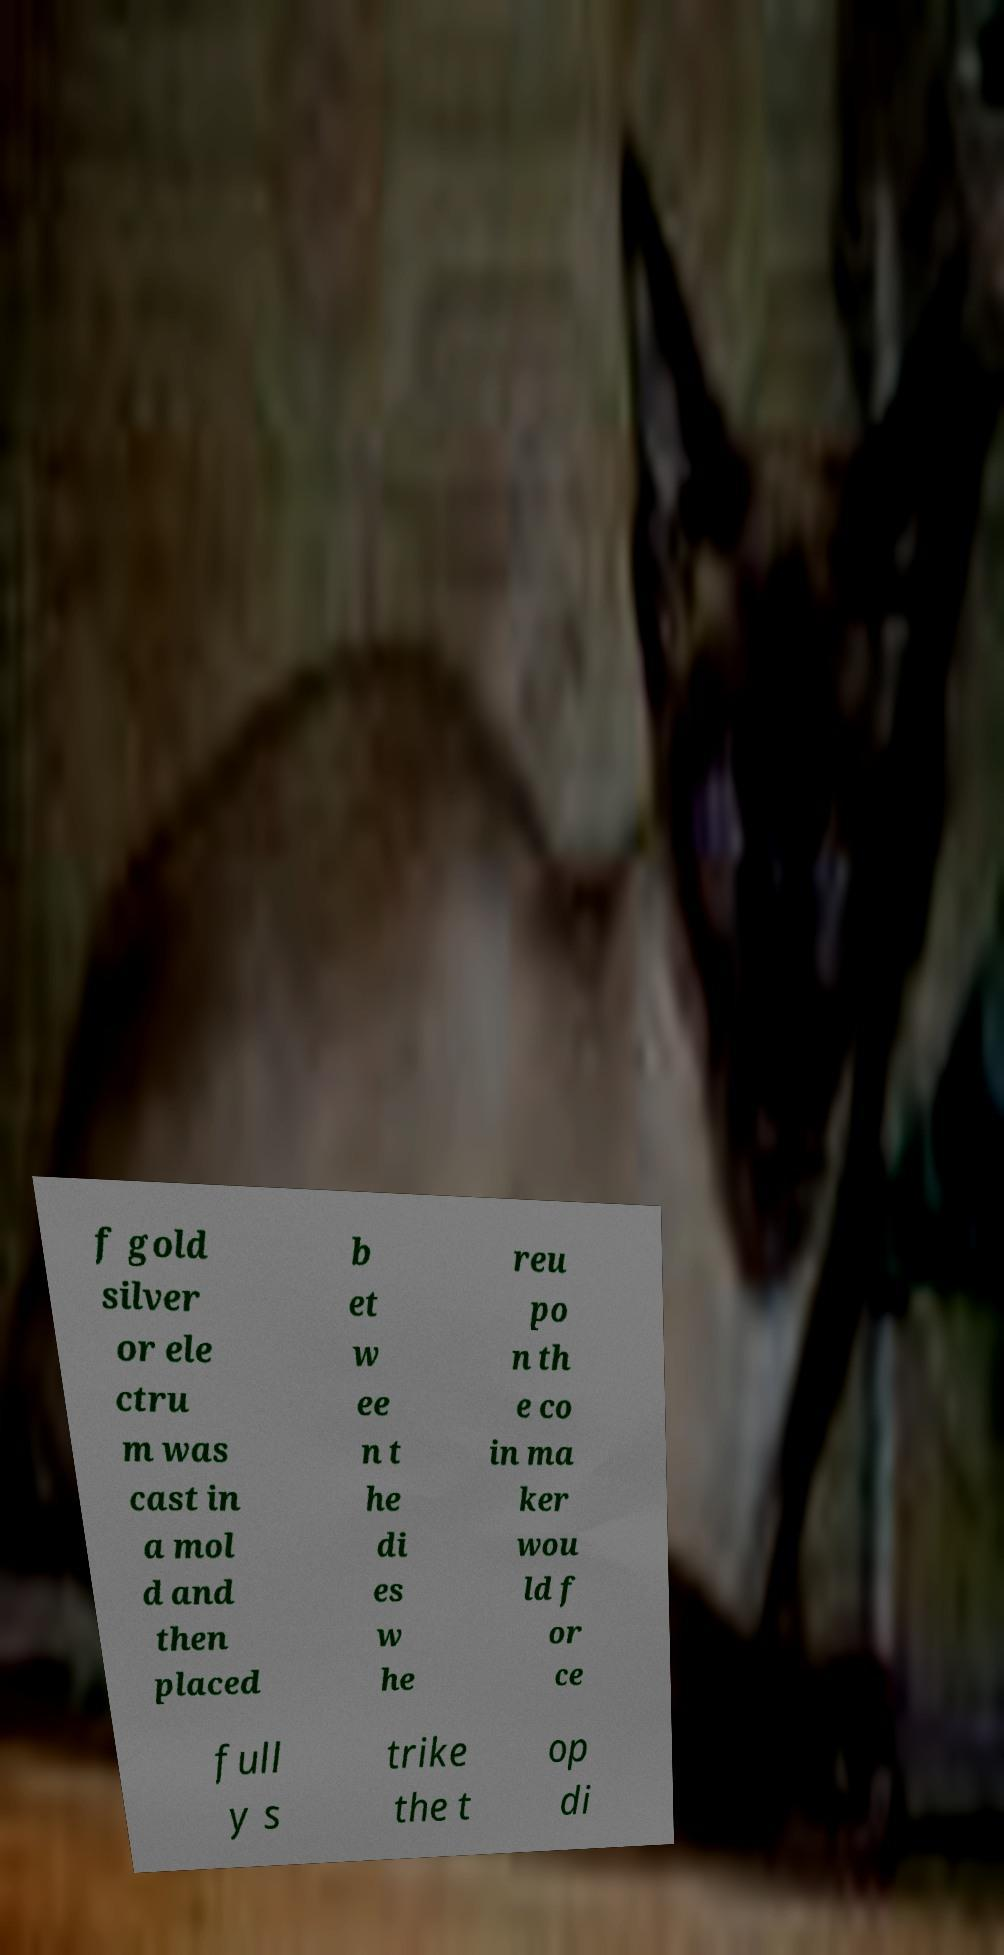I need the written content from this picture converted into text. Can you do that? f gold silver or ele ctru m was cast in a mol d and then placed b et w ee n t he di es w he reu po n th e co in ma ker wou ld f or ce full y s trike the t op di 